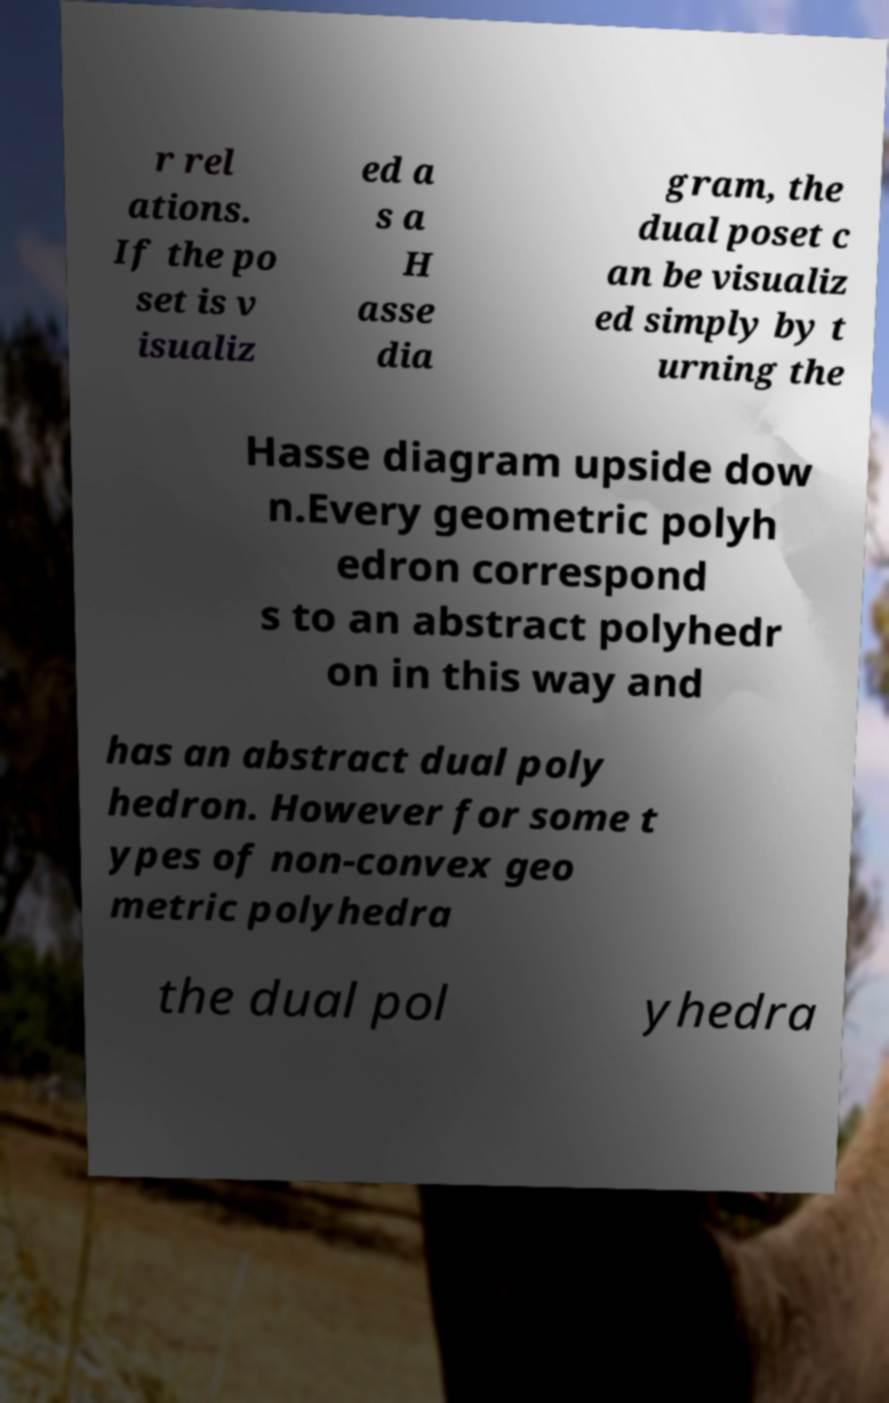Can you accurately transcribe the text from the provided image for me? r rel ations. If the po set is v isualiz ed a s a H asse dia gram, the dual poset c an be visualiz ed simply by t urning the Hasse diagram upside dow n.Every geometric polyh edron correspond s to an abstract polyhedr on in this way and has an abstract dual poly hedron. However for some t ypes of non-convex geo metric polyhedra the dual pol yhedra 